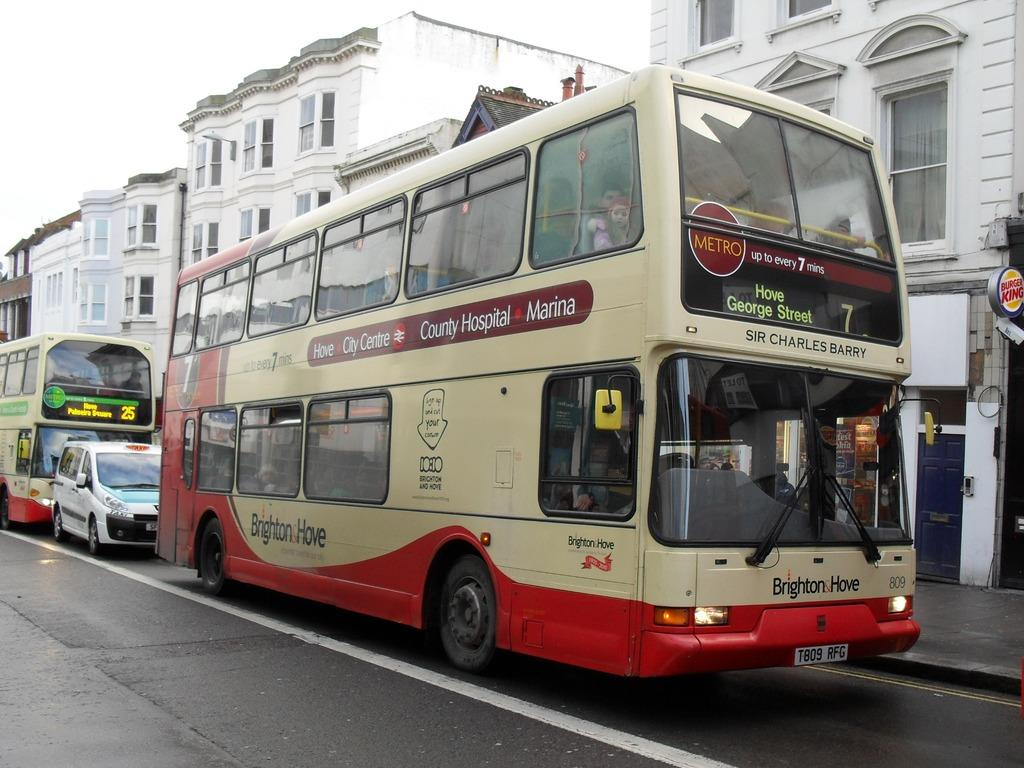<image>
Provide a brief description of the given image. A double decker bus from Brighton and Hove is running the number 7 route. 